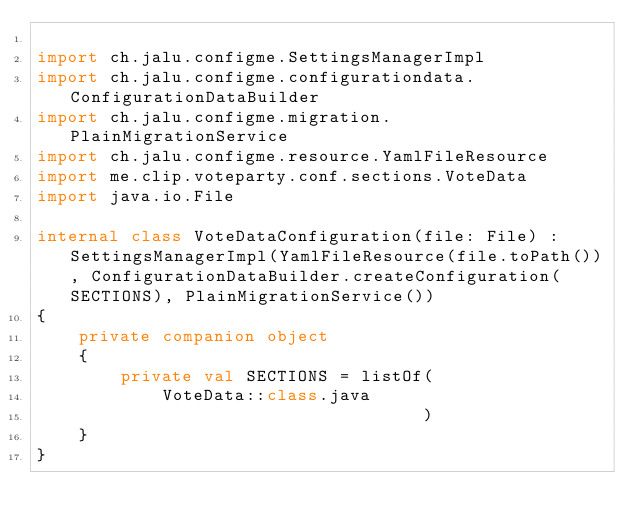<code> <loc_0><loc_0><loc_500><loc_500><_Kotlin_>
import ch.jalu.configme.SettingsManagerImpl
import ch.jalu.configme.configurationdata.ConfigurationDataBuilder
import ch.jalu.configme.migration.PlainMigrationService
import ch.jalu.configme.resource.YamlFileResource
import me.clip.voteparty.conf.sections.VoteData
import java.io.File

internal class VoteDataConfiguration(file: File) : SettingsManagerImpl(YamlFileResource(file.toPath()), ConfigurationDataBuilder.createConfiguration(SECTIONS), PlainMigrationService())
{
	private companion object
	{
		private val SECTIONS = listOf(
			VoteData::class.java
		                             )
	}
}</code> 